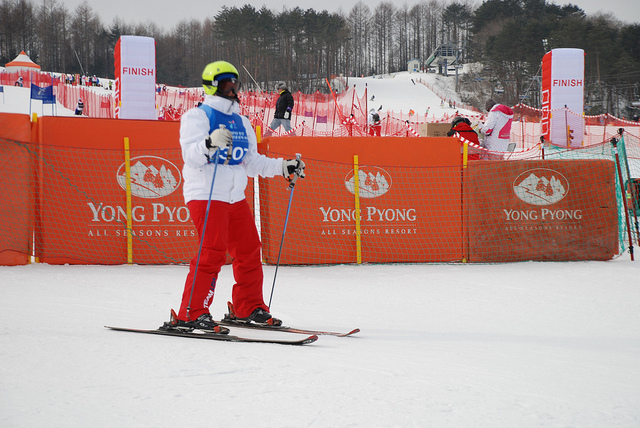Please extract the text content from this image. FINISH YONG PYO YONG PYONG ALL SEASONS RES PYONG YONG RESORT SEASONS ALL 0 FINISH 